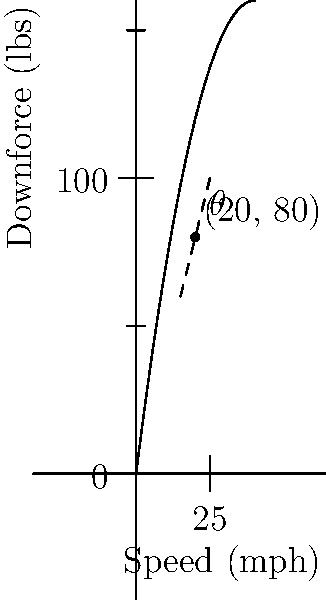As a car enthusiast helping beginners understand aerodynamics, you're explaining how to find the best angle for a car spoiler. The graph shows the relationship between a car's speed and the downforce generated by the spoiler. The curve's peak represents the optimal setup. Using coordinate geometry, what's the best angle (in degrees) for the spoiler when the car is at its most efficient speed? Let's break this down step-by-step:

1) The peak of the curve represents the optimal point where downforce is maximized. This occurs at the point (20, 80) on our graph.

2) To find the angle of the spoiler, we need to calculate the slope of the tangent line at this point. The tangent line represents the rate of change at that specific point.

3) We can estimate the slope using two nearby points on the tangent line. Let's use (15, 60) and (25, 100).

4) The slope formula is:
   $m = \frac{y_2 - y_1}{x_2 - x_1} = \frac{100 - 60}{25 - 15} = \frac{40}{10} = 4$

5) Now, we can use the arctangent function to convert this slope into an angle:
   $\theta = \arctan(m) = \arctan(4)$

6) Using a calculator or computer, we find:
   $\arctan(4) \approx 75.96$ degrees

7) In car aerodynamics, we typically measure the spoiler angle from the horizontal, not the vertical. So we need to subtract this from 90°:
   $90° - 75.96° \approx 14.04°$

8) Rounding to the nearest degree for practical application:
   $14.04° \approx 14°$

This 14° angle represents the optimal spoiler position when the car is at its most efficient speed (20 mph in this case).
Answer: 14° 